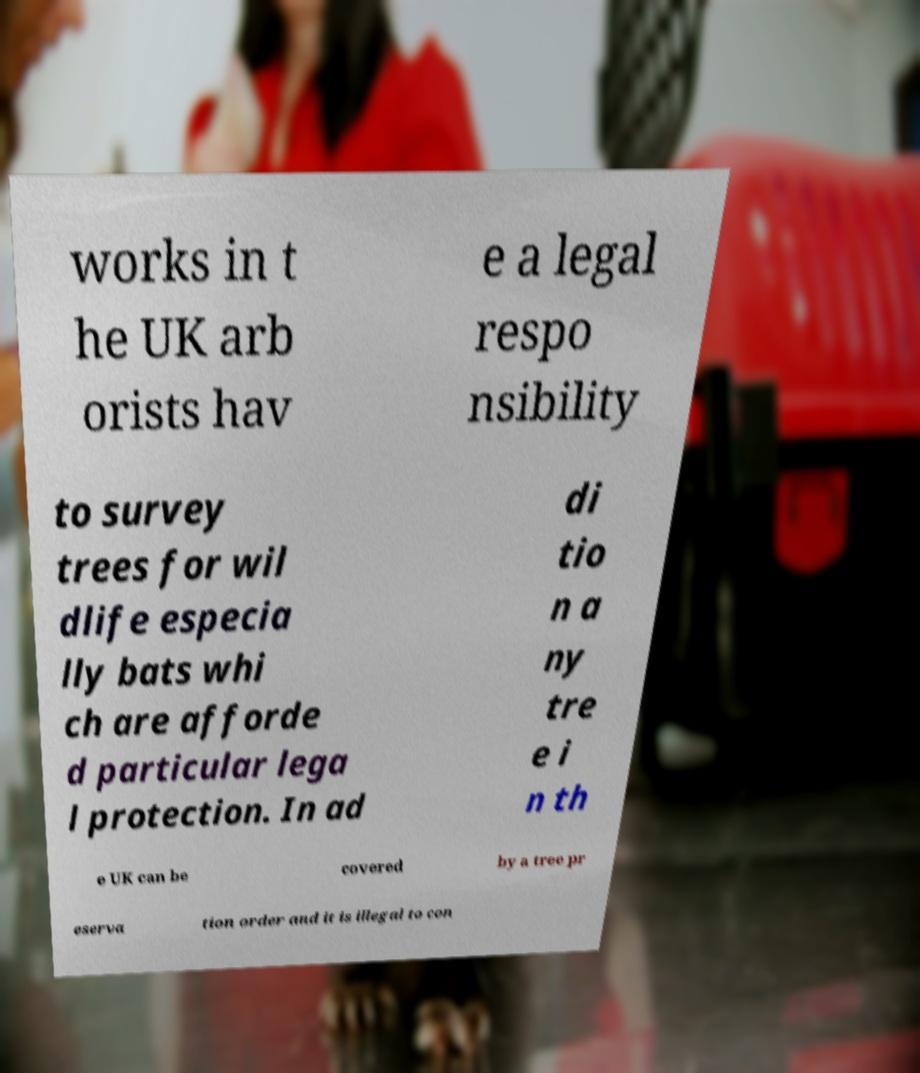Could you assist in decoding the text presented in this image and type it out clearly? works in t he UK arb orists hav e a legal respo nsibility to survey trees for wil dlife especia lly bats whi ch are afforde d particular lega l protection. In ad di tio n a ny tre e i n th e UK can be covered by a tree pr eserva tion order and it is illegal to con 